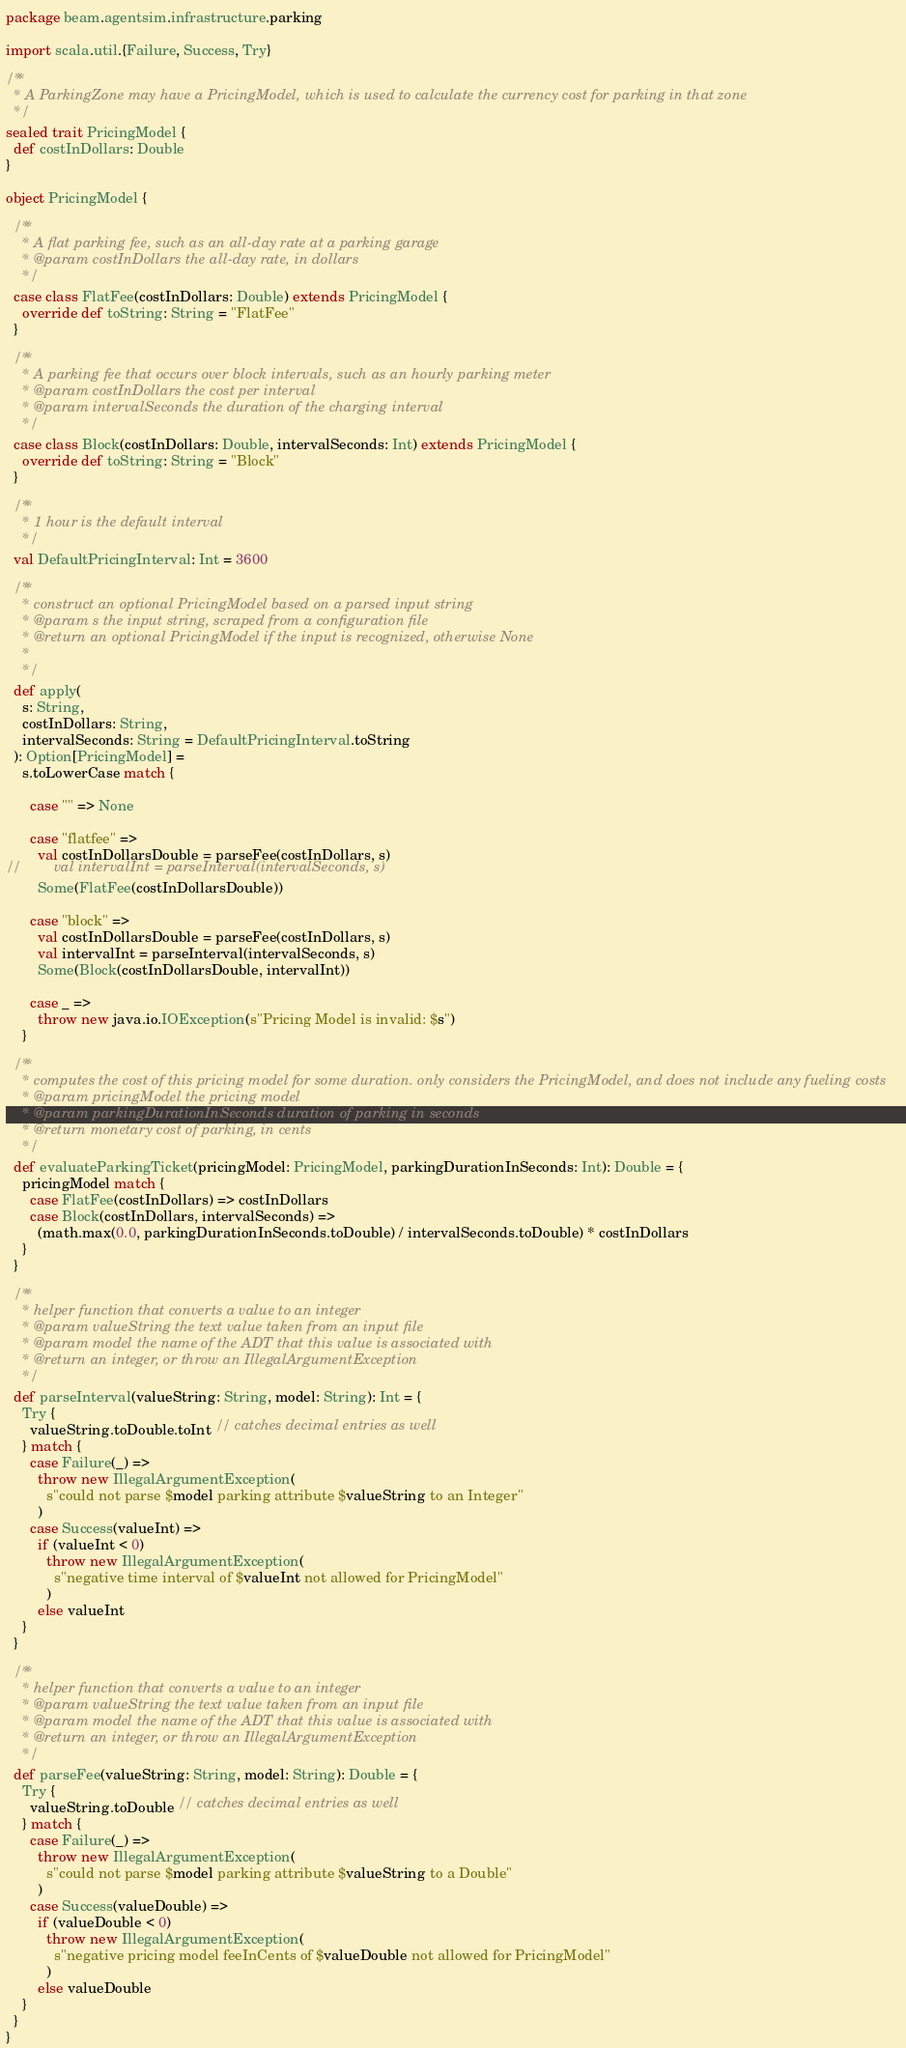Convert code to text. <code><loc_0><loc_0><loc_500><loc_500><_Scala_>package beam.agentsim.infrastructure.parking

import scala.util.{Failure, Success, Try}

/**
  * A ParkingZone may have a PricingModel, which is used to calculate the currency cost for parking in that zone
  */
sealed trait PricingModel {
  def costInDollars: Double
}

object PricingModel {

  /**
    * A flat parking fee, such as an all-day rate at a parking garage
    * @param costInDollars the all-day rate, in dollars
    */
  case class FlatFee(costInDollars: Double) extends PricingModel {
    override def toString: String = "FlatFee"
  }

  /**
    * A parking fee that occurs over block intervals, such as an hourly parking meter
    * @param costInDollars the cost per interval
    * @param intervalSeconds the duration of the charging interval
    */
  case class Block(costInDollars: Double, intervalSeconds: Int) extends PricingModel {
    override def toString: String = "Block"
  }

  /**
    * 1 hour is the default interval
    */
  val DefaultPricingInterval: Int = 3600

  /**
    * construct an optional PricingModel based on a parsed input string
    * @param s the input string, scraped from a configuration file
    * @return an optional PricingModel if the input is recognized, otherwise None
    *
    */
  def apply(
    s: String,
    costInDollars: String,
    intervalSeconds: String = DefaultPricingInterval.toString
  ): Option[PricingModel] =
    s.toLowerCase match {

      case "" => None

      case "flatfee" =>
        val costInDollarsDouble = parseFee(costInDollars, s)
//        val intervalInt = parseInterval(intervalSeconds, s)
        Some(FlatFee(costInDollarsDouble))

      case "block" =>
        val costInDollarsDouble = parseFee(costInDollars, s)
        val intervalInt = parseInterval(intervalSeconds, s)
        Some(Block(costInDollarsDouble, intervalInt))

      case _ =>
        throw new java.io.IOException(s"Pricing Model is invalid: $s")
    }

  /**
    * computes the cost of this pricing model for some duration. only considers the PricingModel, and does not include any fueling costs
    * @param pricingModel the pricing model
    * @param parkingDurationInSeconds duration of parking in seconds
    * @return monetary cost of parking, in cents
    */
  def evaluateParkingTicket(pricingModel: PricingModel, parkingDurationInSeconds: Int): Double = {
    pricingModel match {
      case FlatFee(costInDollars) => costInDollars
      case Block(costInDollars, intervalSeconds) =>
        (math.max(0.0, parkingDurationInSeconds.toDouble) / intervalSeconds.toDouble) * costInDollars
    }
  }

  /**
    * helper function that converts a value to an integer
    * @param valueString the text value taken from an input file
    * @param model the name of the ADT that this value is associated with
    * @return an integer, or throw an IllegalArgumentException
    */
  def parseInterval(valueString: String, model: String): Int = {
    Try {
      valueString.toDouble.toInt // catches decimal entries as well
    } match {
      case Failure(_) =>
        throw new IllegalArgumentException(
          s"could not parse $model parking attribute $valueString to an Integer"
        )
      case Success(valueInt) =>
        if (valueInt < 0)
          throw new IllegalArgumentException(
            s"negative time interval of $valueInt not allowed for PricingModel"
          )
        else valueInt
    }
  }

  /**
    * helper function that converts a value to an integer
    * @param valueString the text value taken from an input file
    * @param model the name of the ADT that this value is associated with
    * @return an integer, or throw an IllegalArgumentException
    */
  def parseFee(valueString: String, model: String): Double = {
    Try {
      valueString.toDouble // catches decimal entries as well
    } match {
      case Failure(_) =>
        throw new IllegalArgumentException(
          s"could not parse $model parking attribute $valueString to a Double"
        )
      case Success(valueDouble) =>
        if (valueDouble < 0)
          throw new IllegalArgumentException(
            s"negative pricing model feeInCents of $valueDouble not allowed for PricingModel"
          )
        else valueDouble
    }
  }
}
</code> 